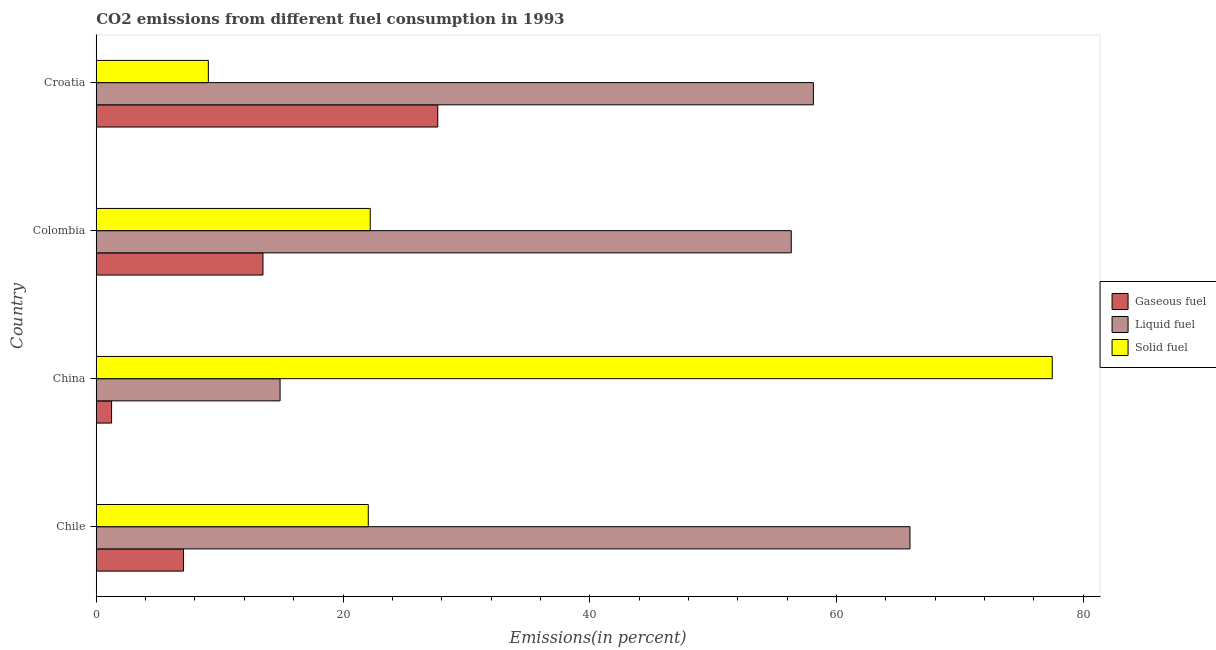How many groups of bars are there?
Offer a very short reply. 4. How many bars are there on the 4th tick from the top?
Make the answer very short. 3. How many bars are there on the 4th tick from the bottom?
Offer a terse response. 3. What is the label of the 2nd group of bars from the top?
Ensure brevity in your answer.  Colombia. What is the percentage of liquid fuel emission in Colombia?
Ensure brevity in your answer.  56.33. Across all countries, what is the maximum percentage of gaseous fuel emission?
Ensure brevity in your answer.  27.68. Across all countries, what is the minimum percentage of liquid fuel emission?
Offer a very short reply. 14.9. In which country was the percentage of gaseous fuel emission maximum?
Provide a succinct answer. Croatia. In which country was the percentage of solid fuel emission minimum?
Your answer should be very brief. Croatia. What is the total percentage of liquid fuel emission in the graph?
Your response must be concise. 195.31. What is the difference between the percentage of solid fuel emission in China and that in Croatia?
Give a very brief answer. 68.4. What is the difference between the percentage of liquid fuel emission in China and the percentage of gaseous fuel emission in Colombia?
Your answer should be compact. 1.39. What is the average percentage of gaseous fuel emission per country?
Offer a terse response. 12.38. What is the difference between the percentage of liquid fuel emission and percentage of solid fuel emission in Chile?
Offer a terse response. 43.91. In how many countries, is the percentage of gaseous fuel emission greater than 68 %?
Offer a very short reply. 0. What is the ratio of the percentage of gaseous fuel emission in Chile to that in Croatia?
Ensure brevity in your answer.  0.26. Is the difference between the percentage of gaseous fuel emission in Colombia and Croatia greater than the difference between the percentage of liquid fuel emission in Colombia and Croatia?
Give a very brief answer. No. What is the difference between the highest and the second highest percentage of liquid fuel emission?
Keep it short and to the point. 7.83. What is the difference between the highest and the lowest percentage of liquid fuel emission?
Ensure brevity in your answer.  51.05. In how many countries, is the percentage of liquid fuel emission greater than the average percentage of liquid fuel emission taken over all countries?
Give a very brief answer. 3. Is the sum of the percentage of solid fuel emission in Colombia and Croatia greater than the maximum percentage of liquid fuel emission across all countries?
Your response must be concise. No. What does the 1st bar from the top in Colombia represents?
Provide a succinct answer. Solid fuel. What does the 3rd bar from the bottom in China represents?
Keep it short and to the point. Solid fuel. How many bars are there?
Provide a short and direct response. 12. Are the values on the major ticks of X-axis written in scientific E-notation?
Offer a terse response. No. Does the graph contain any zero values?
Keep it short and to the point. No. Does the graph contain grids?
Your answer should be very brief. No. Where does the legend appear in the graph?
Give a very brief answer. Center right. What is the title of the graph?
Provide a short and direct response. CO2 emissions from different fuel consumption in 1993. Does "Resident buildings and public services" appear as one of the legend labels in the graph?
Ensure brevity in your answer.  No. What is the label or title of the X-axis?
Ensure brevity in your answer.  Emissions(in percent). What is the label or title of the Y-axis?
Offer a very short reply. Country. What is the Emissions(in percent) of Gaseous fuel in Chile?
Your answer should be very brief. 7.07. What is the Emissions(in percent) in Liquid fuel in Chile?
Offer a terse response. 65.95. What is the Emissions(in percent) of Solid fuel in Chile?
Your answer should be compact. 22.05. What is the Emissions(in percent) in Gaseous fuel in China?
Your answer should be compact. 1.24. What is the Emissions(in percent) in Liquid fuel in China?
Provide a succinct answer. 14.9. What is the Emissions(in percent) in Solid fuel in China?
Give a very brief answer. 77.49. What is the Emissions(in percent) of Gaseous fuel in Colombia?
Offer a terse response. 13.51. What is the Emissions(in percent) in Liquid fuel in Colombia?
Provide a succinct answer. 56.33. What is the Emissions(in percent) of Solid fuel in Colombia?
Your response must be concise. 22.21. What is the Emissions(in percent) in Gaseous fuel in Croatia?
Keep it short and to the point. 27.68. What is the Emissions(in percent) in Liquid fuel in Croatia?
Keep it short and to the point. 58.12. What is the Emissions(in percent) of Solid fuel in Croatia?
Provide a short and direct response. 9.08. Across all countries, what is the maximum Emissions(in percent) of Gaseous fuel?
Keep it short and to the point. 27.68. Across all countries, what is the maximum Emissions(in percent) of Liquid fuel?
Give a very brief answer. 65.95. Across all countries, what is the maximum Emissions(in percent) in Solid fuel?
Your response must be concise. 77.49. Across all countries, what is the minimum Emissions(in percent) in Gaseous fuel?
Your answer should be very brief. 1.24. Across all countries, what is the minimum Emissions(in percent) of Liquid fuel?
Your answer should be compact. 14.9. Across all countries, what is the minimum Emissions(in percent) of Solid fuel?
Offer a terse response. 9.08. What is the total Emissions(in percent) in Gaseous fuel in the graph?
Offer a terse response. 49.51. What is the total Emissions(in percent) of Liquid fuel in the graph?
Provide a short and direct response. 195.31. What is the total Emissions(in percent) in Solid fuel in the graph?
Your answer should be very brief. 130.82. What is the difference between the Emissions(in percent) in Gaseous fuel in Chile and that in China?
Provide a succinct answer. 5.83. What is the difference between the Emissions(in percent) in Liquid fuel in Chile and that in China?
Your answer should be compact. 51.05. What is the difference between the Emissions(in percent) of Solid fuel in Chile and that in China?
Your answer should be very brief. -55.44. What is the difference between the Emissions(in percent) of Gaseous fuel in Chile and that in Colombia?
Give a very brief answer. -6.44. What is the difference between the Emissions(in percent) in Liquid fuel in Chile and that in Colombia?
Ensure brevity in your answer.  9.62. What is the difference between the Emissions(in percent) of Solid fuel in Chile and that in Colombia?
Keep it short and to the point. -0.16. What is the difference between the Emissions(in percent) in Gaseous fuel in Chile and that in Croatia?
Your answer should be very brief. -20.6. What is the difference between the Emissions(in percent) of Liquid fuel in Chile and that in Croatia?
Offer a terse response. 7.83. What is the difference between the Emissions(in percent) in Solid fuel in Chile and that in Croatia?
Your answer should be very brief. 12.96. What is the difference between the Emissions(in percent) in Gaseous fuel in China and that in Colombia?
Your answer should be compact. -12.27. What is the difference between the Emissions(in percent) of Liquid fuel in China and that in Colombia?
Offer a very short reply. -41.43. What is the difference between the Emissions(in percent) in Solid fuel in China and that in Colombia?
Keep it short and to the point. 55.28. What is the difference between the Emissions(in percent) in Gaseous fuel in China and that in Croatia?
Your answer should be very brief. -26.44. What is the difference between the Emissions(in percent) of Liquid fuel in China and that in Croatia?
Your response must be concise. -43.23. What is the difference between the Emissions(in percent) in Solid fuel in China and that in Croatia?
Make the answer very short. 68.4. What is the difference between the Emissions(in percent) in Gaseous fuel in Colombia and that in Croatia?
Your response must be concise. -14.17. What is the difference between the Emissions(in percent) of Liquid fuel in Colombia and that in Croatia?
Ensure brevity in your answer.  -1.79. What is the difference between the Emissions(in percent) of Solid fuel in Colombia and that in Croatia?
Your response must be concise. 13.12. What is the difference between the Emissions(in percent) of Gaseous fuel in Chile and the Emissions(in percent) of Liquid fuel in China?
Offer a terse response. -7.83. What is the difference between the Emissions(in percent) of Gaseous fuel in Chile and the Emissions(in percent) of Solid fuel in China?
Keep it short and to the point. -70.41. What is the difference between the Emissions(in percent) in Liquid fuel in Chile and the Emissions(in percent) in Solid fuel in China?
Your response must be concise. -11.53. What is the difference between the Emissions(in percent) of Gaseous fuel in Chile and the Emissions(in percent) of Liquid fuel in Colombia?
Keep it short and to the point. -49.26. What is the difference between the Emissions(in percent) of Gaseous fuel in Chile and the Emissions(in percent) of Solid fuel in Colombia?
Make the answer very short. -15.13. What is the difference between the Emissions(in percent) of Liquid fuel in Chile and the Emissions(in percent) of Solid fuel in Colombia?
Provide a short and direct response. 43.75. What is the difference between the Emissions(in percent) of Gaseous fuel in Chile and the Emissions(in percent) of Liquid fuel in Croatia?
Your answer should be very brief. -51.05. What is the difference between the Emissions(in percent) in Gaseous fuel in Chile and the Emissions(in percent) in Solid fuel in Croatia?
Give a very brief answer. -2.01. What is the difference between the Emissions(in percent) in Liquid fuel in Chile and the Emissions(in percent) in Solid fuel in Croatia?
Provide a short and direct response. 56.87. What is the difference between the Emissions(in percent) of Gaseous fuel in China and the Emissions(in percent) of Liquid fuel in Colombia?
Ensure brevity in your answer.  -55.09. What is the difference between the Emissions(in percent) of Gaseous fuel in China and the Emissions(in percent) of Solid fuel in Colombia?
Offer a very short reply. -20.96. What is the difference between the Emissions(in percent) of Liquid fuel in China and the Emissions(in percent) of Solid fuel in Colombia?
Your answer should be very brief. -7.31. What is the difference between the Emissions(in percent) in Gaseous fuel in China and the Emissions(in percent) in Liquid fuel in Croatia?
Offer a terse response. -56.88. What is the difference between the Emissions(in percent) of Gaseous fuel in China and the Emissions(in percent) of Solid fuel in Croatia?
Your response must be concise. -7.84. What is the difference between the Emissions(in percent) of Liquid fuel in China and the Emissions(in percent) of Solid fuel in Croatia?
Offer a very short reply. 5.81. What is the difference between the Emissions(in percent) in Gaseous fuel in Colombia and the Emissions(in percent) in Liquid fuel in Croatia?
Your answer should be compact. -44.61. What is the difference between the Emissions(in percent) in Gaseous fuel in Colombia and the Emissions(in percent) in Solid fuel in Croatia?
Offer a terse response. 4.43. What is the difference between the Emissions(in percent) of Liquid fuel in Colombia and the Emissions(in percent) of Solid fuel in Croatia?
Give a very brief answer. 47.25. What is the average Emissions(in percent) in Gaseous fuel per country?
Keep it short and to the point. 12.38. What is the average Emissions(in percent) of Liquid fuel per country?
Provide a succinct answer. 48.83. What is the average Emissions(in percent) in Solid fuel per country?
Provide a succinct answer. 32.71. What is the difference between the Emissions(in percent) in Gaseous fuel and Emissions(in percent) in Liquid fuel in Chile?
Give a very brief answer. -58.88. What is the difference between the Emissions(in percent) of Gaseous fuel and Emissions(in percent) of Solid fuel in Chile?
Offer a terse response. -14.97. What is the difference between the Emissions(in percent) in Liquid fuel and Emissions(in percent) in Solid fuel in Chile?
Ensure brevity in your answer.  43.91. What is the difference between the Emissions(in percent) in Gaseous fuel and Emissions(in percent) in Liquid fuel in China?
Ensure brevity in your answer.  -13.66. What is the difference between the Emissions(in percent) in Gaseous fuel and Emissions(in percent) in Solid fuel in China?
Ensure brevity in your answer.  -76.24. What is the difference between the Emissions(in percent) of Liquid fuel and Emissions(in percent) of Solid fuel in China?
Your answer should be very brief. -62.59. What is the difference between the Emissions(in percent) of Gaseous fuel and Emissions(in percent) of Liquid fuel in Colombia?
Offer a terse response. -42.82. What is the difference between the Emissions(in percent) in Gaseous fuel and Emissions(in percent) in Solid fuel in Colombia?
Provide a succinct answer. -8.69. What is the difference between the Emissions(in percent) of Liquid fuel and Emissions(in percent) of Solid fuel in Colombia?
Offer a terse response. 34.13. What is the difference between the Emissions(in percent) in Gaseous fuel and Emissions(in percent) in Liquid fuel in Croatia?
Give a very brief answer. -30.45. What is the difference between the Emissions(in percent) of Gaseous fuel and Emissions(in percent) of Solid fuel in Croatia?
Give a very brief answer. 18.59. What is the difference between the Emissions(in percent) of Liquid fuel and Emissions(in percent) of Solid fuel in Croatia?
Your answer should be very brief. 49.04. What is the ratio of the Emissions(in percent) of Gaseous fuel in Chile to that in China?
Provide a succinct answer. 5.7. What is the ratio of the Emissions(in percent) in Liquid fuel in Chile to that in China?
Provide a succinct answer. 4.43. What is the ratio of the Emissions(in percent) in Solid fuel in Chile to that in China?
Ensure brevity in your answer.  0.28. What is the ratio of the Emissions(in percent) of Gaseous fuel in Chile to that in Colombia?
Make the answer very short. 0.52. What is the ratio of the Emissions(in percent) of Liquid fuel in Chile to that in Colombia?
Your response must be concise. 1.17. What is the ratio of the Emissions(in percent) of Gaseous fuel in Chile to that in Croatia?
Your answer should be very brief. 0.26. What is the ratio of the Emissions(in percent) in Liquid fuel in Chile to that in Croatia?
Offer a terse response. 1.13. What is the ratio of the Emissions(in percent) in Solid fuel in Chile to that in Croatia?
Keep it short and to the point. 2.43. What is the ratio of the Emissions(in percent) in Gaseous fuel in China to that in Colombia?
Give a very brief answer. 0.09. What is the ratio of the Emissions(in percent) of Liquid fuel in China to that in Colombia?
Keep it short and to the point. 0.26. What is the ratio of the Emissions(in percent) in Solid fuel in China to that in Colombia?
Your answer should be compact. 3.49. What is the ratio of the Emissions(in percent) of Gaseous fuel in China to that in Croatia?
Keep it short and to the point. 0.04. What is the ratio of the Emissions(in percent) of Liquid fuel in China to that in Croatia?
Ensure brevity in your answer.  0.26. What is the ratio of the Emissions(in percent) of Solid fuel in China to that in Croatia?
Offer a very short reply. 8.53. What is the ratio of the Emissions(in percent) in Gaseous fuel in Colombia to that in Croatia?
Make the answer very short. 0.49. What is the ratio of the Emissions(in percent) in Liquid fuel in Colombia to that in Croatia?
Ensure brevity in your answer.  0.97. What is the ratio of the Emissions(in percent) in Solid fuel in Colombia to that in Croatia?
Your answer should be compact. 2.44. What is the difference between the highest and the second highest Emissions(in percent) of Gaseous fuel?
Your answer should be very brief. 14.17. What is the difference between the highest and the second highest Emissions(in percent) in Liquid fuel?
Give a very brief answer. 7.83. What is the difference between the highest and the second highest Emissions(in percent) in Solid fuel?
Offer a very short reply. 55.28. What is the difference between the highest and the lowest Emissions(in percent) in Gaseous fuel?
Ensure brevity in your answer.  26.44. What is the difference between the highest and the lowest Emissions(in percent) of Liquid fuel?
Your answer should be very brief. 51.05. What is the difference between the highest and the lowest Emissions(in percent) in Solid fuel?
Your response must be concise. 68.4. 